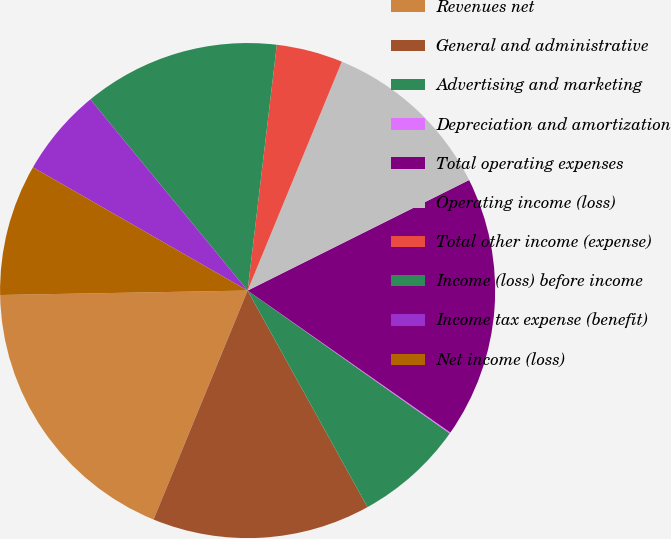Convert chart to OTSL. <chart><loc_0><loc_0><loc_500><loc_500><pie_chart><fcel>Revenues net<fcel>General and administrative<fcel>Advertising and marketing<fcel>Depreciation and amortization<fcel>Total operating expenses<fcel>Operating income (loss)<fcel>Total other income (expense)<fcel>Income (loss) before income<fcel>Income tax expense (benefit)<fcel>Net income (loss)<nl><fcel>18.51%<fcel>14.25%<fcel>7.16%<fcel>0.07%<fcel>17.09%<fcel>11.42%<fcel>4.33%<fcel>12.84%<fcel>5.75%<fcel>8.58%<nl></chart> 